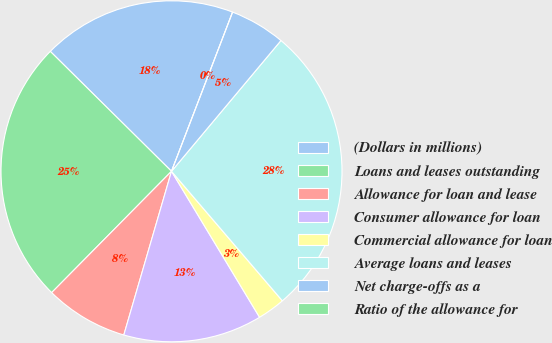Convert chart. <chart><loc_0><loc_0><loc_500><loc_500><pie_chart><fcel>(Dollars in millions)<fcel>Loans and leases outstanding<fcel>Allowance for loan and lease<fcel>Consumer allowance for loan<fcel>Commercial allowance for loan<fcel>Average loans and leases<fcel>Net charge-offs as a<fcel>Ratio of the allowance for<nl><fcel>18.42%<fcel>25.01%<fcel>7.89%<fcel>13.15%<fcel>2.63%<fcel>27.64%<fcel>5.26%<fcel>0.0%<nl></chart> 